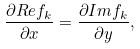<formula> <loc_0><loc_0><loc_500><loc_500>\frac { \partial R e f _ { k } } { \partial x } = \frac { \partial I m f _ { k } } { \partial y } ,</formula> 